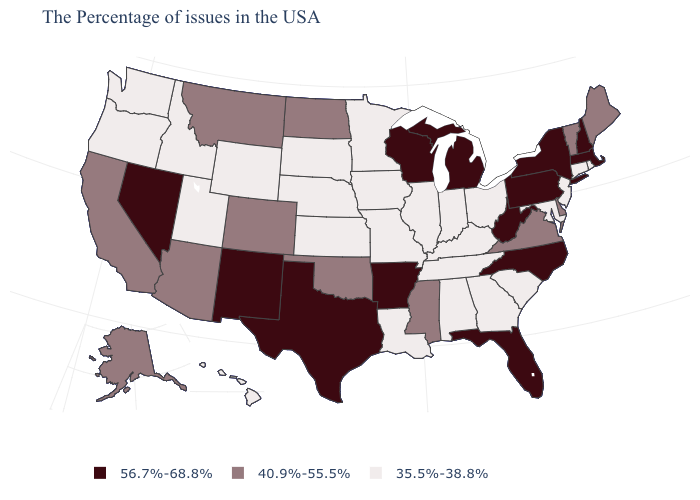What is the value of Alaska?
Short answer required. 40.9%-55.5%. What is the value of Connecticut?
Keep it brief. 35.5%-38.8%. Does Maryland have the lowest value in the South?
Short answer required. Yes. Which states have the lowest value in the South?
Short answer required. Maryland, South Carolina, Georgia, Kentucky, Alabama, Tennessee, Louisiana. What is the value of New Mexico?
Be succinct. 56.7%-68.8%. Among the states that border Missouri , which have the lowest value?
Short answer required. Kentucky, Tennessee, Illinois, Iowa, Kansas, Nebraska. What is the value of Montana?
Short answer required. 40.9%-55.5%. What is the highest value in the USA?
Write a very short answer. 56.7%-68.8%. Name the states that have a value in the range 35.5%-38.8%?
Be succinct. Rhode Island, Connecticut, New Jersey, Maryland, South Carolina, Ohio, Georgia, Kentucky, Indiana, Alabama, Tennessee, Illinois, Louisiana, Missouri, Minnesota, Iowa, Kansas, Nebraska, South Dakota, Wyoming, Utah, Idaho, Washington, Oregon, Hawaii. Among the states that border South Dakota , which have the highest value?
Keep it brief. North Dakota, Montana. What is the value of Montana?
Keep it brief. 40.9%-55.5%. Which states have the highest value in the USA?
Be succinct. Massachusetts, New Hampshire, New York, Pennsylvania, North Carolina, West Virginia, Florida, Michigan, Wisconsin, Arkansas, Texas, New Mexico, Nevada. Does Pennsylvania have the highest value in the USA?
Quick response, please. Yes. Does New York have a higher value than Utah?
Answer briefly. Yes. What is the value of Pennsylvania?
Write a very short answer. 56.7%-68.8%. 